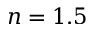<formula> <loc_0><loc_0><loc_500><loc_500>n = 1 . 5</formula> 